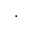<formula> <loc_0><loc_0><loc_500><loc_500>\cdot</formula> 